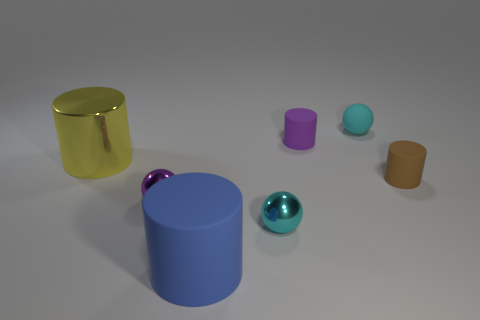Subtract all metal cylinders. How many cylinders are left? 3 Subtract 2 spheres. How many spheres are left? 1 Subtract all purple cylinders. How many cylinders are left? 3 Add 1 tiny cyan matte objects. How many objects exist? 8 Subtract all cylinders. How many objects are left? 3 Add 5 metallic cylinders. How many metallic cylinders exist? 6 Subtract 0 blue cubes. How many objects are left? 7 Subtract all blue spheres. Subtract all red cubes. How many spheres are left? 3 Subtract all brown cylinders. How many red balls are left? 0 Subtract all green balls. Subtract all purple metal objects. How many objects are left? 6 